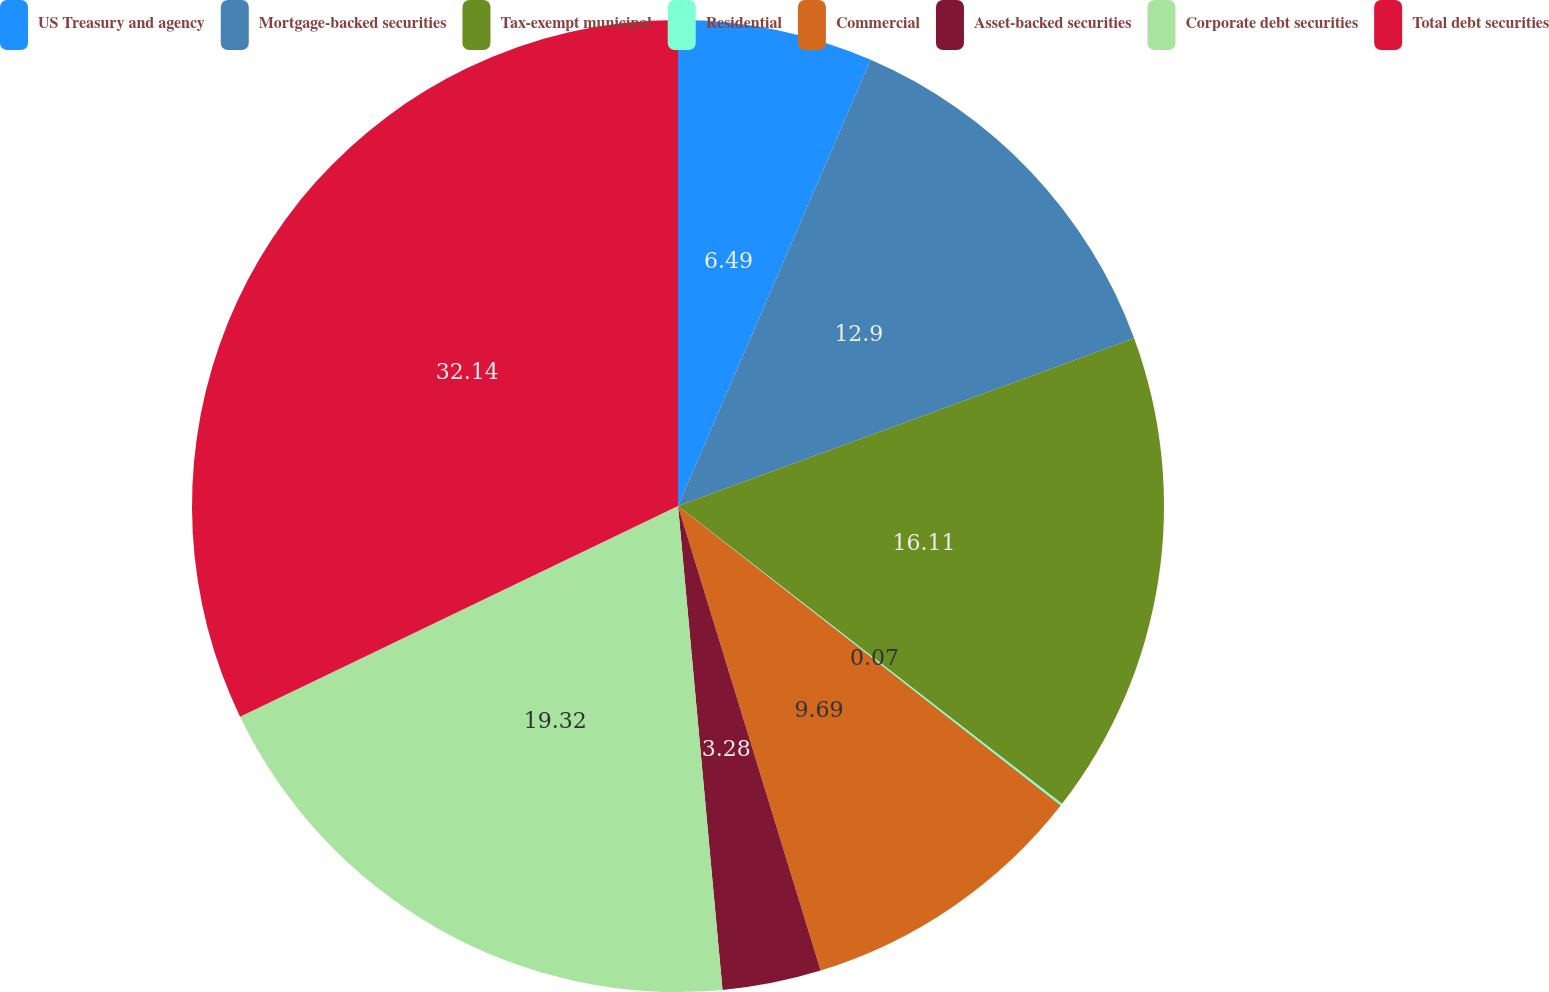Convert chart. <chart><loc_0><loc_0><loc_500><loc_500><pie_chart><fcel>US Treasury and agency<fcel>Mortgage-backed securities<fcel>Tax-exempt municipal<fcel>Residential<fcel>Commercial<fcel>Asset-backed securities<fcel>Corporate debt securities<fcel>Total debt securities<nl><fcel>6.49%<fcel>12.9%<fcel>16.11%<fcel>0.07%<fcel>9.69%<fcel>3.28%<fcel>19.32%<fcel>32.14%<nl></chart> 